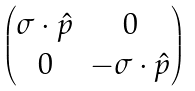<formula> <loc_0><loc_0><loc_500><loc_500>\begin{pmatrix} \sigma \cdot \hat { p } & 0 \\ 0 & - \sigma \cdot \hat { p } \end{pmatrix}</formula> 